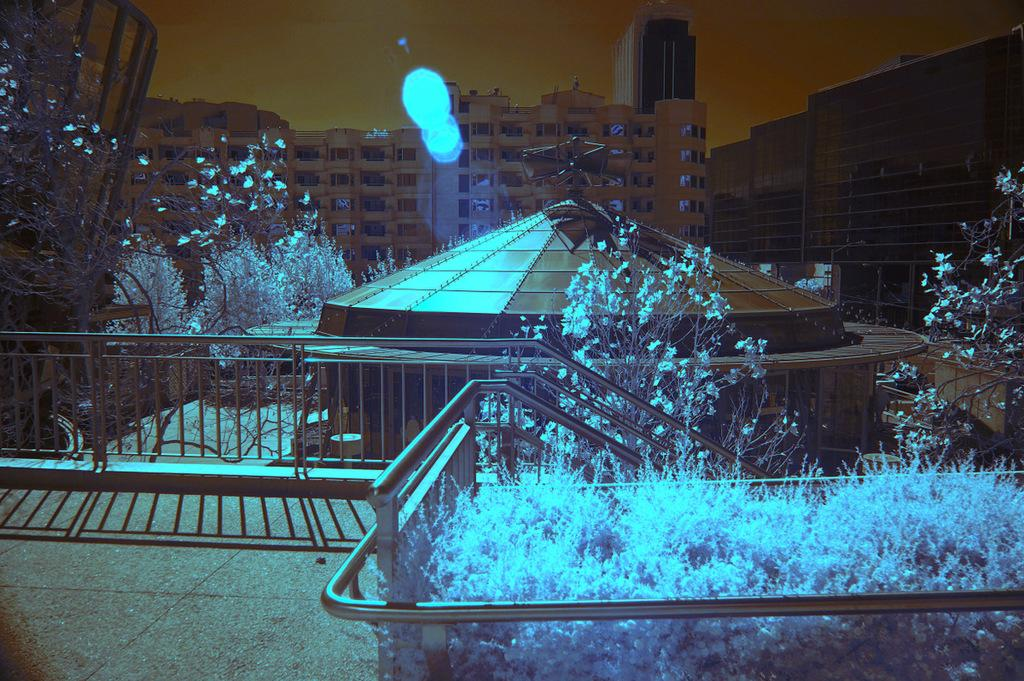What color are the plants in the image? The plants in the image are blue. What other natural elements can be seen in the image? There are trees in the image. What type of man-made structures are present in the image? There are buildings in the image. What feature can be seen that might be used for safety or support? There is a railing in the image. What effect of light can be observed in the image? There is a shadow visible in the image. What type of toys can be seen playing with the yak in the image? There is no yak or toys present in the image. 